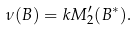Convert formula to latex. <formula><loc_0><loc_0><loc_500><loc_500>\nu ( B ) = k M _ { 2 } ^ { \prime } ( B ^ { * } ) .</formula> 